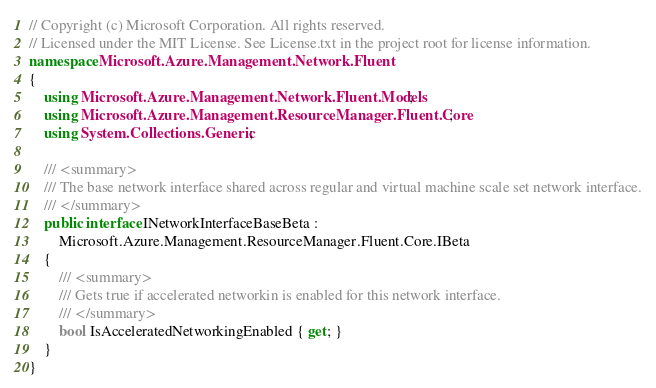Convert code to text. <code><loc_0><loc_0><loc_500><loc_500><_C#_>// Copyright (c) Microsoft Corporation. All rights reserved.
// Licensed under the MIT License. See License.txt in the project root for license information.
namespace Microsoft.Azure.Management.Network.Fluent
{
    using Microsoft.Azure.Management.Network.Fluent.Models;
    using Microsoft.Azure.Management.ResourceManager.Fluent.Core;
    using System.Collections.Generic;

    /// <summary>
    /// The base network interface shared across regular and virtual machine scale set network interface.
    /// </summary>
    public interface INetworkInterfaceBaseBeta :
        Microsoft.Azure.Management.ResourceManager.Fluent.Core.IBeta
    {
        /// <summary>
        /// Gets true if accelerated networkin is enabled for this network interface.
        /// </summary>
        bool IsAcceleratedNetworkingEnabled { get; }
    }
}</code> 